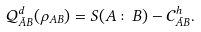<formula> <loc_0><loc_0><loc_500><loc_500>\mathcal { Q } ^ { d } _ { \bar { A } B } ( \rho _ { A B } ) = S ( A \colon B ) - \mathcal { C } ^ { h } _ { \bar { A } B } .</formula> 